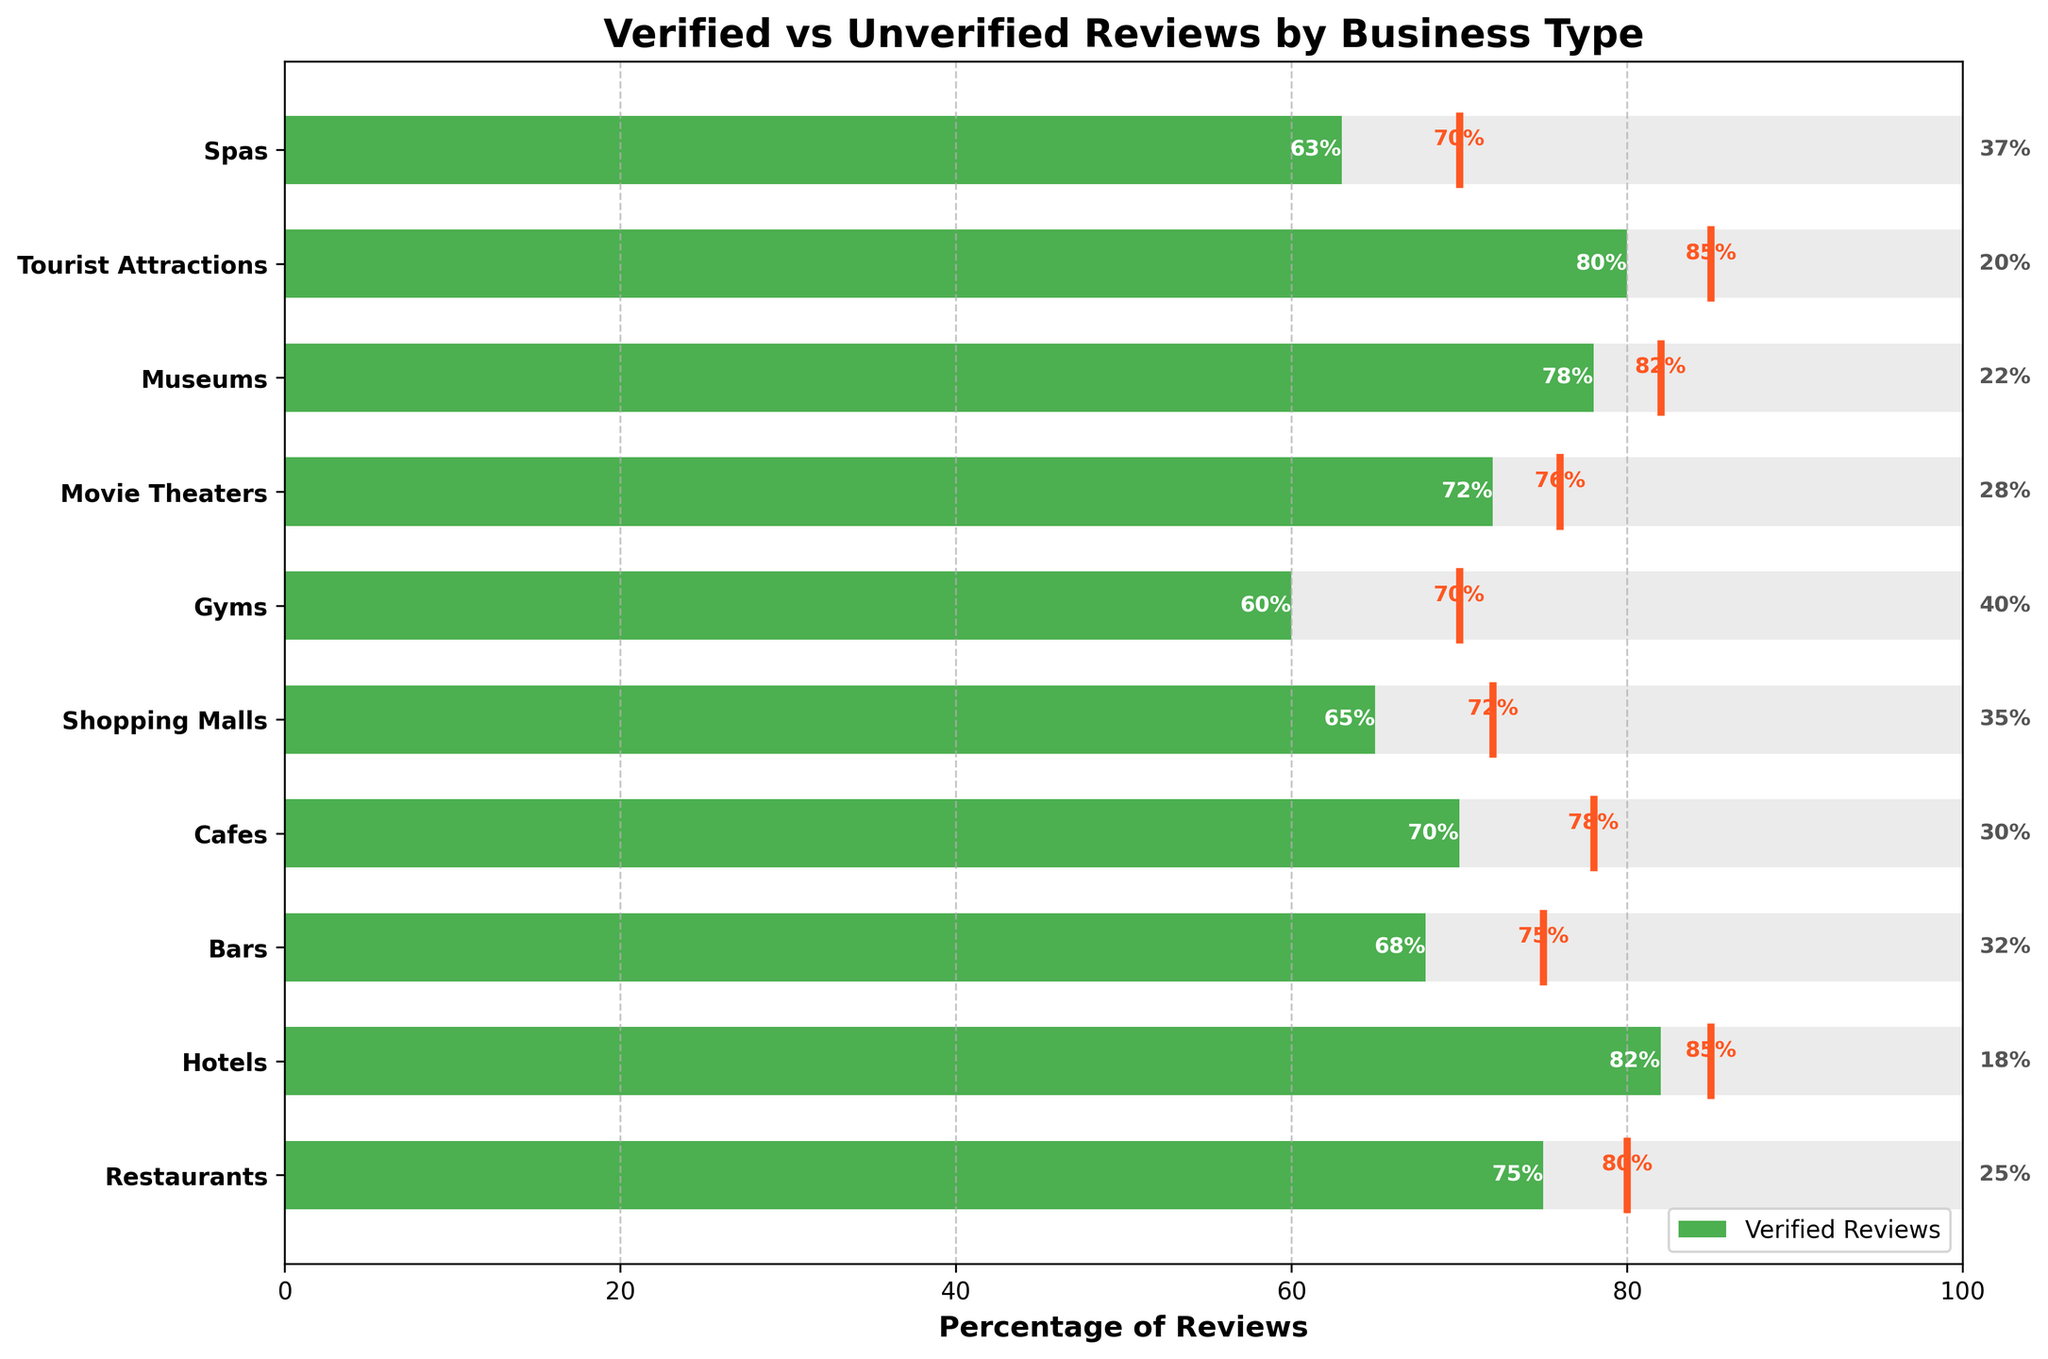What is the title of the figure? The title is typically found at the top of the plot. It gives an overview of what the plot represents. Here, the title is "Verified vs Unverified Reviews by Business Type".
Answer: Verified vs Unverified Reviews by Business Type Which business type has the highest percentage of verified reviews? To determine this, look at the lengths of the green bars representing verified reviews. The longest green bar corresponds to "Hotels" with 82%.
Answer: Hotels Which business type has the lowest percentage of verified reviews? Again, look at the lengths of the green bars and find the shortest one. The shortest green bar corresponds to "Gyms" with 60%.
Answer: Gyms What is the verified review percentage for Tourist Attractions, and how does it compare to its target? First, locate the bar for Tourist Attractions, which shows 80% verified reviews. The target line for Tourist Attractions is at 85%. Comparing them, Tourist Attractions fall short by 5%.
Answer: 80%, 5% short How many business types exceed or meet their target verified review percentage? To find this, compare each business type's green bar length (actual percentage) to the target line. "No business type meets or exceeds its target verified review percentage".
Answer: 0 What is the average percentage of verified reviews across all business types? Sum all the percentages of verified reviews and divide by the number of business types: (75 + 82 + 68 + 70 + 65 + 60 + 72 + 78 + 80 + 63) / 10 = 71.3%.
Answer: 71.3% Which business type shows the largest gap between its actual verified review percentage and its target? Calculate the difference between each business type's verified review percentage and its target. "Gyms" have the largest gap of 70 - 60 = 10%.
Answer: Gyms What are the colors used to represent verified and unverified reviews? The bars for verified reviews are green, and the background bars for unverified reviews are gray. The target lines are orange.
Answer: Green, Gray, Orange How many business types have more than 70% but less than 80% verified reviews? Identify business types with green bars between 70% and 80%. These are "Restaurants", "Cafes", "Movie Theaters", and "Museums" making it 4.
Answer: 4 